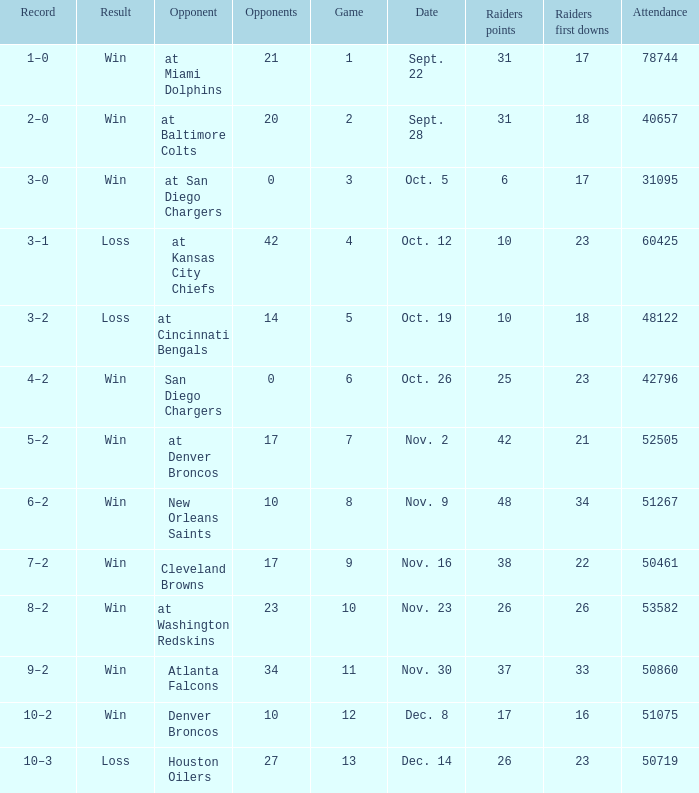Who was the game attended by 60425 people played against? At kansas city chiefs. 